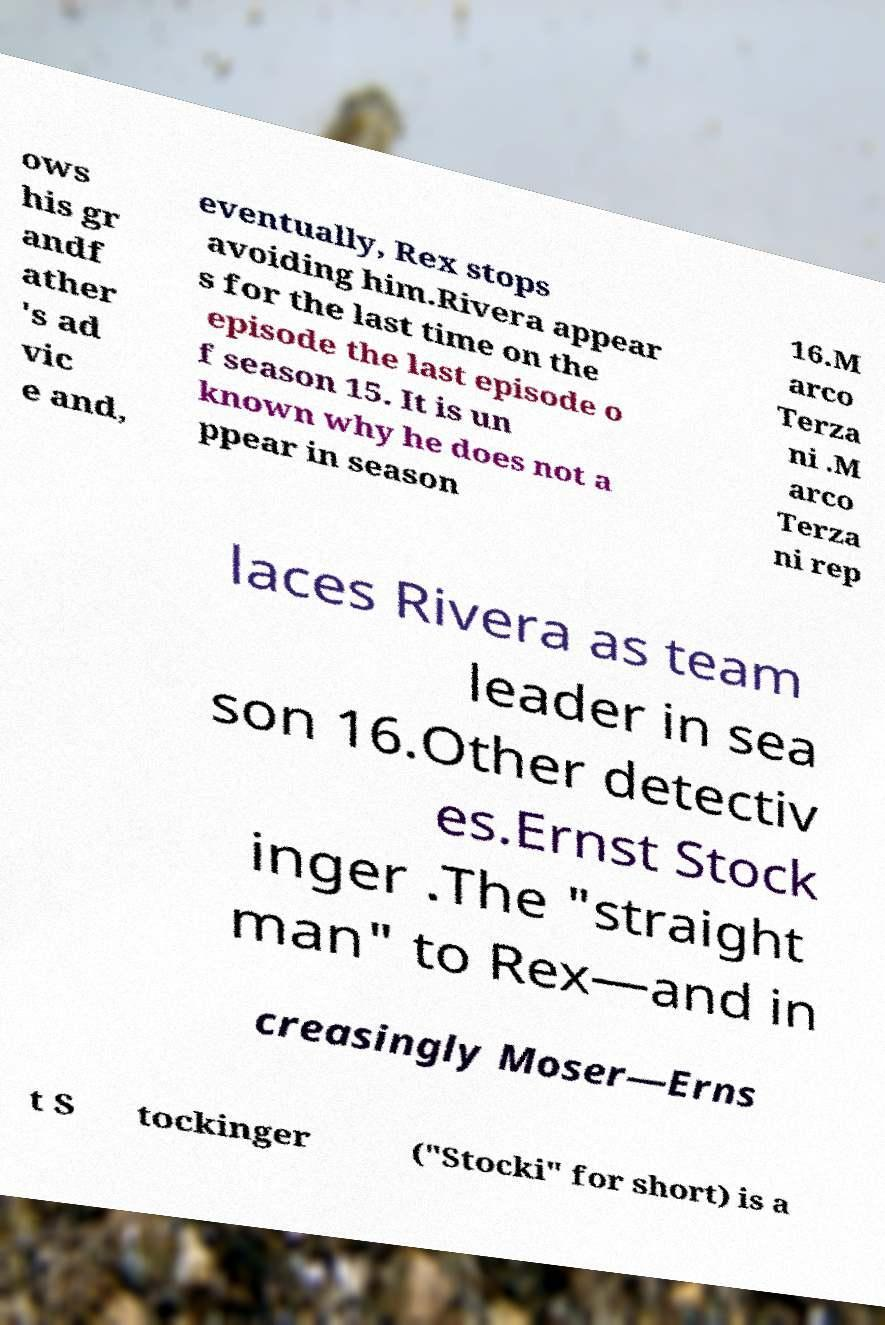Could you extract and type out the text from this image? ows his gr andf ather 's ad vic e and, eventually, Rex stops avoiding him.Rivera appear s for the last time on the episode the last episode o f season 15. It is un known why he does not a ppear in season 16.M arco Terza ni .M arco Terza ni rep laces Rivera as team leader in sea son 16.Other detectiv es.Ernst Stock inger .The "straight man" to Rex—and in creasingly Moser—Erns t S tockinger ("Stocki" for short) is a 